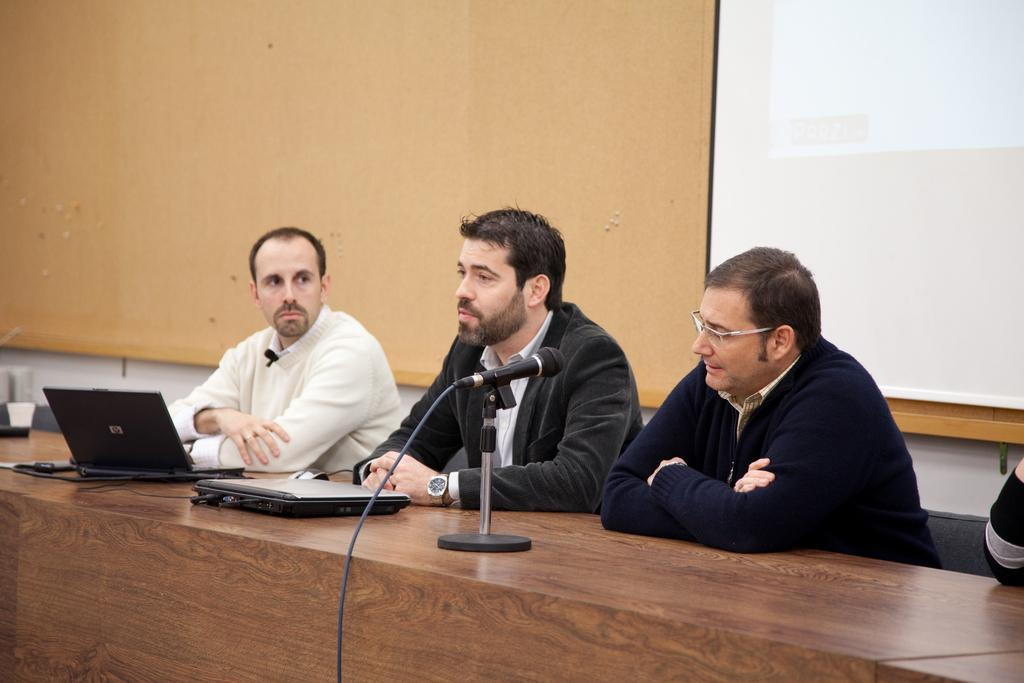What are the people in the image doing? The people are sitting in chairs in the image. Where are the people located in relation to the table? The people are in front of a table in the image. What electronic devices can be seen on the table? There are laptops on the table in the image. What type of audio equipment is on the table? There is a mic on the table in the image. What other objects are present on the table? There are other objects on the table in the image. What is displayed on the wall behind the people? There is a screen on the wall behind the people in the image. What type of bird is sitting on the person's shoulder in the image? A: There is no bird present in the image; the people are sitting in chairs with laptops and a mic on the table. 